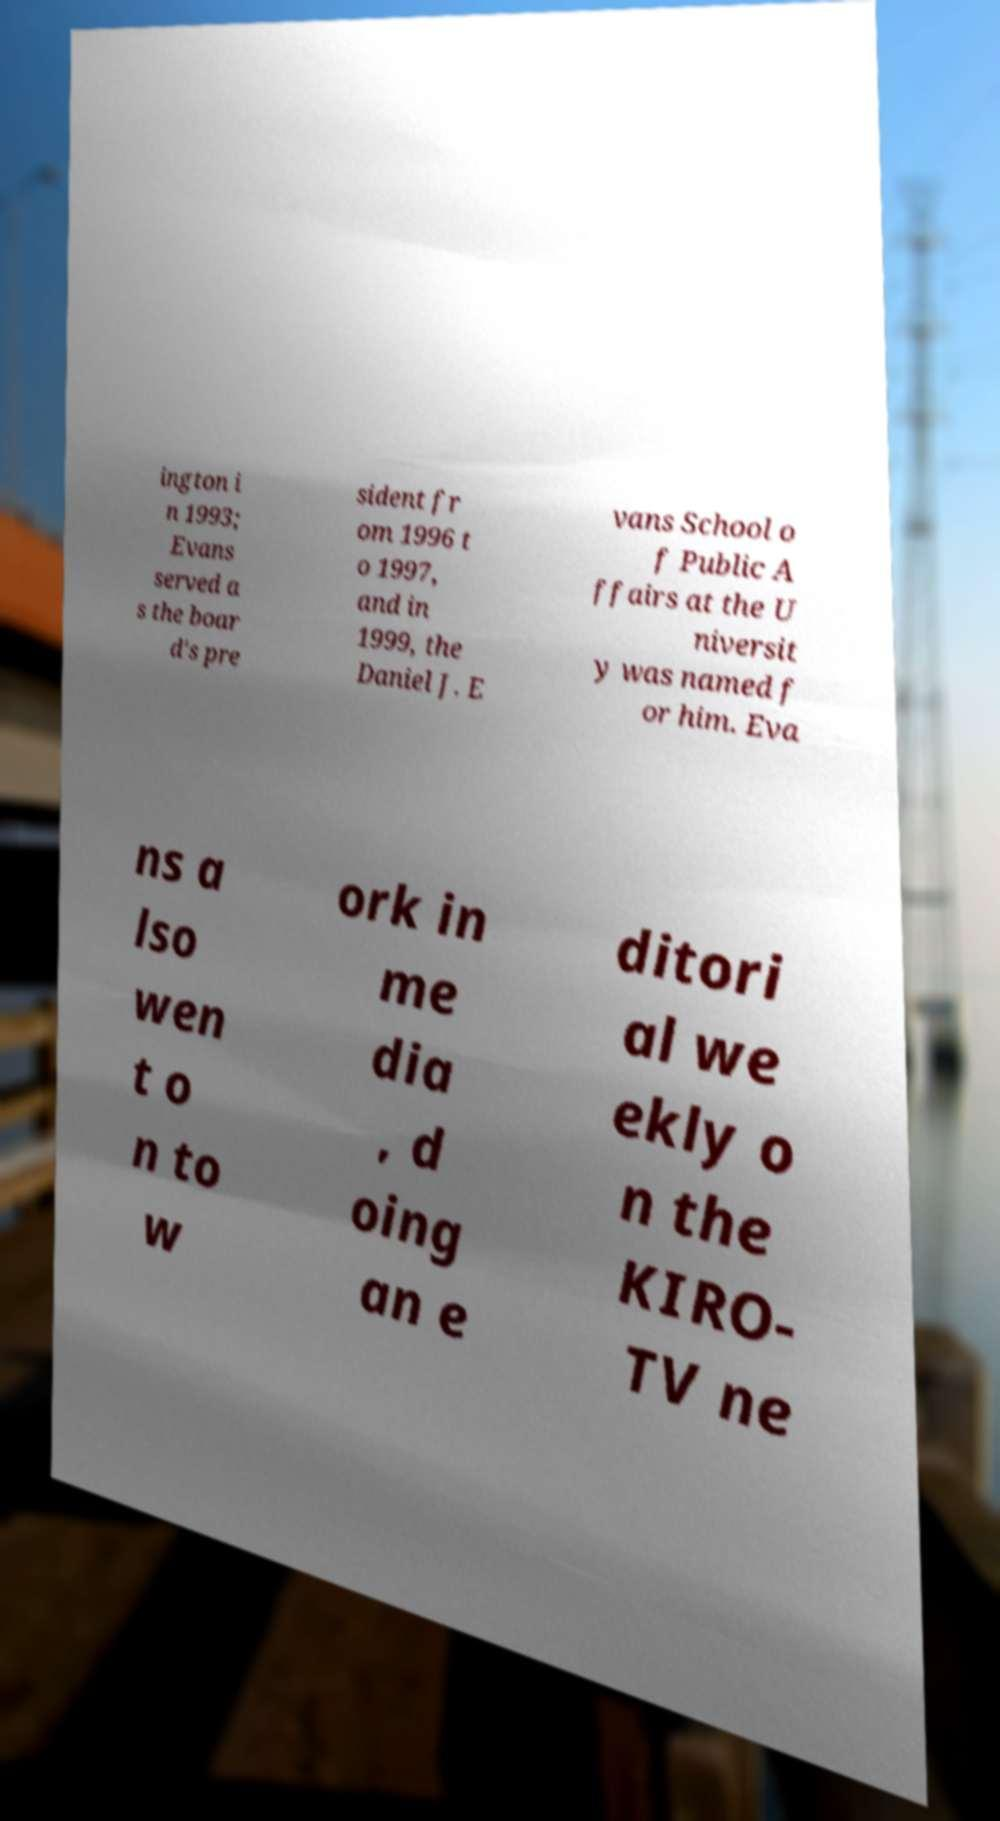Can you accurately transcribe the text from the provided image for me? ington i n 1993; Evans served a s the boar d's pre sident fr om 1996 t o 1997, and in 1999, the Daniel J. E vans School o f Public A ffairs at the U niversit y was named f or him. Eva ns a lso wen t o n to w ork in me dia , d oing an e ditori al we ekly o n the KIRO- TV ne 